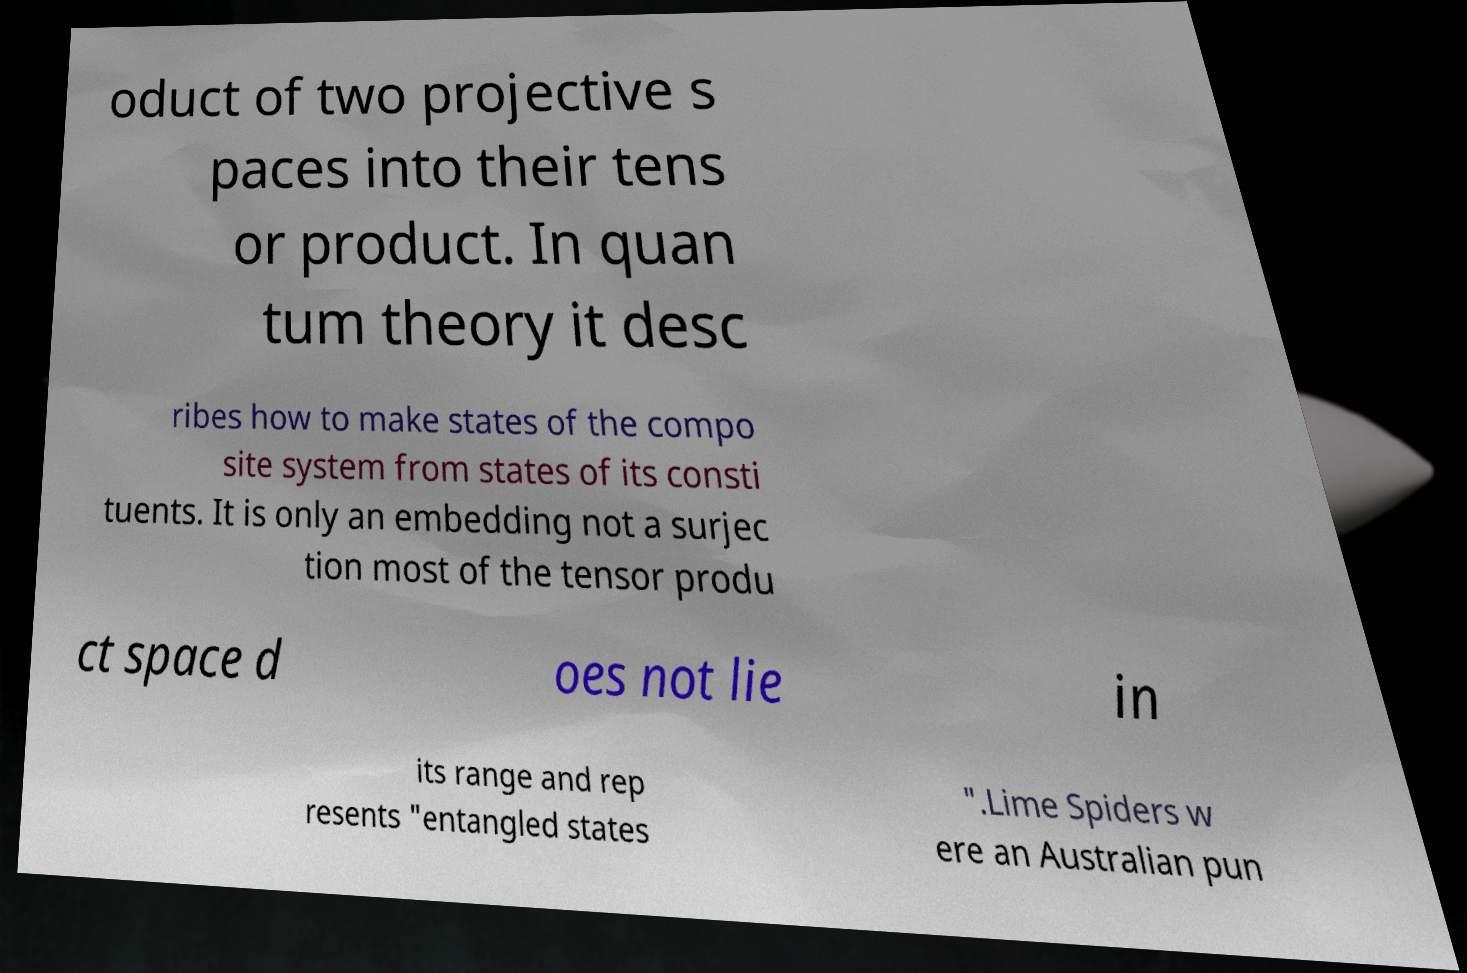Please read and relay the text visible in this image. What does it say? oduct of two projective s paces into their tens or product. In quan tum theory it desc ribes how to make states of the compo site system from states of its consti tuents. It is only an embedding not a surjec tion most of the tensor produ ct space d oes not lie in its range and rep resents "entangled states ".Lime Spiders w ere an Australian pun 